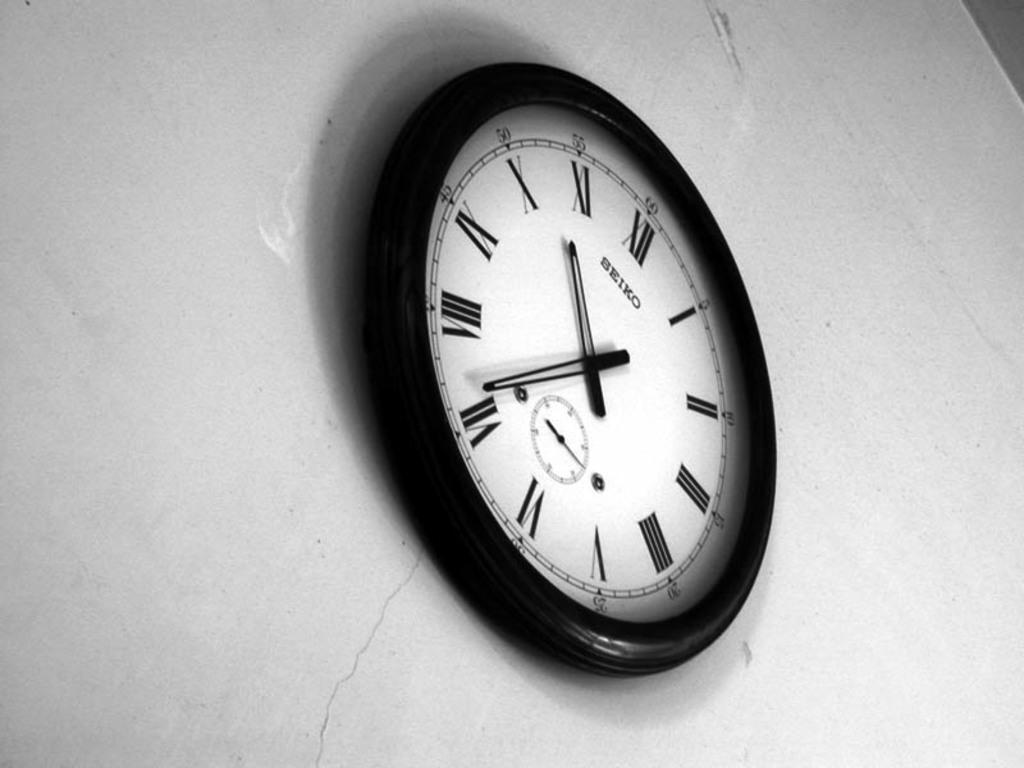In one or two sentences, can you explain what this image depicts? In this image we can see a clock on the wall. 